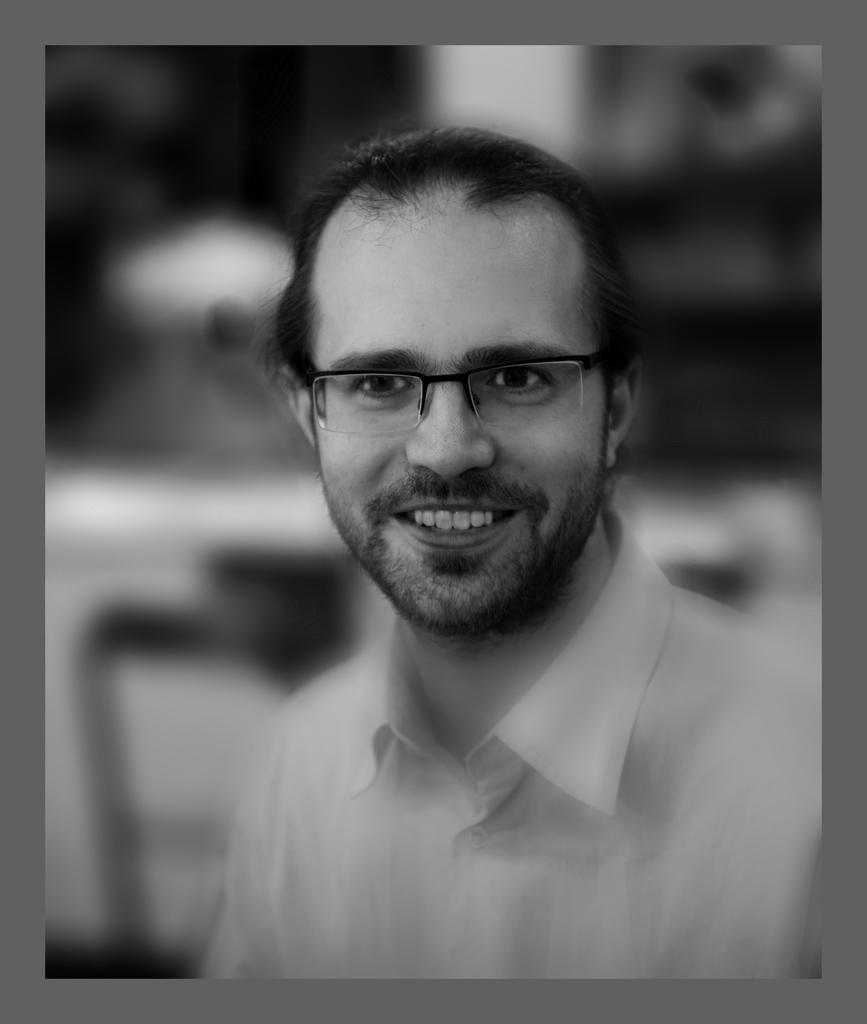What is the color scheme of the image? The image is black and white. Who is present in the image? There is a man in the image. What is the man wearing in the image? The man is wearing glasses in the image. What is the man's facial expression in the image? The man is smiling in the image. What can be observed about the image's borders? The image has borders. How would you describe the background of the image? The background of the image is blurred. What type of dinosaurs can be seen in the image? There are no dinosaurs present in the image; it features a man wearing glasses and smiling. Can you tell me how many faucets are visible in the image? There are no faucets present in the image. 